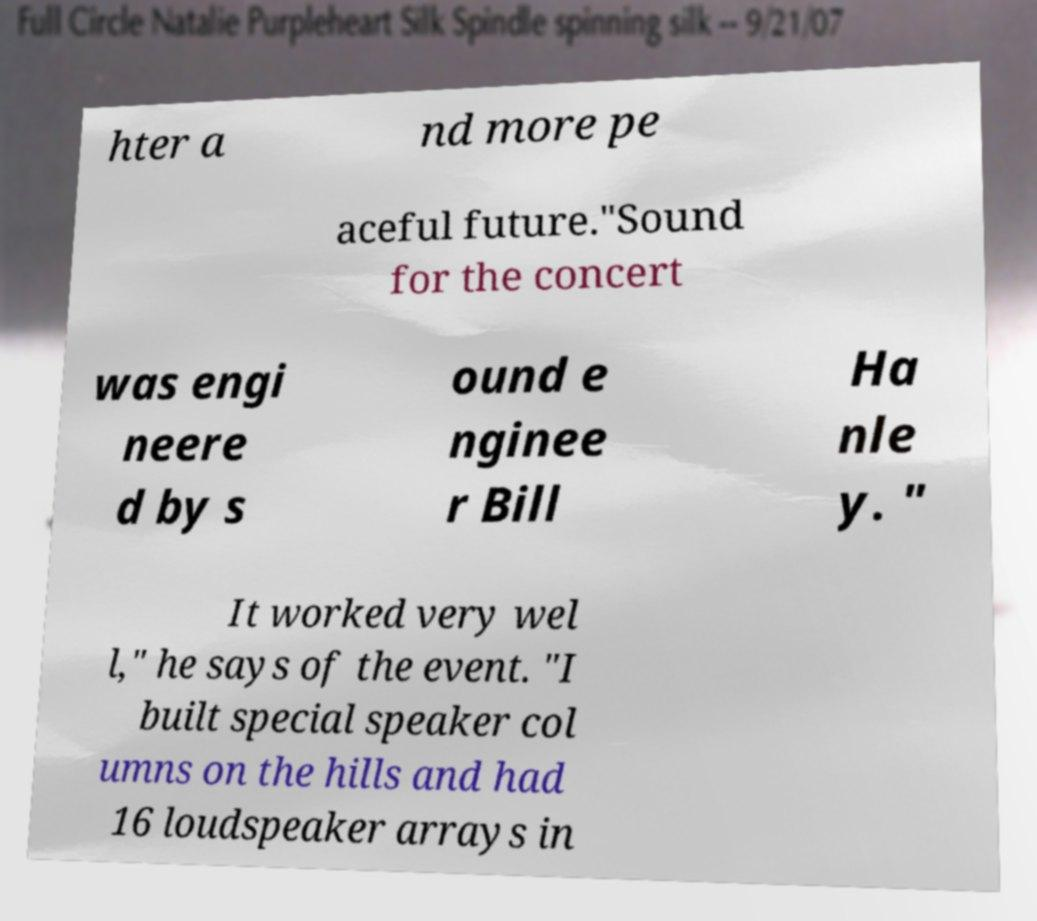Can you read and provide the text displayed in the image?This photo seems to have some interesting text. Can you extract and type it out for me? hter a nd more pe aceful future."Sound for the concert was engi neere d by s ound e nginee r Bill Ha nle y. " It worked very wel l," he says of the event. "I built special speaker col umns on the hills and had 16 loudspeaker arrays in 